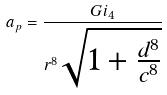<formula> <loc_0><loc_0><loc_500><loc_500>a _ { p } = \frac { G i _ { 4 } } { r ^ { 8 } \sqrt { 1 + \frac { d ^ { 8 } } { c ^ { 8 } } } }</formula> 